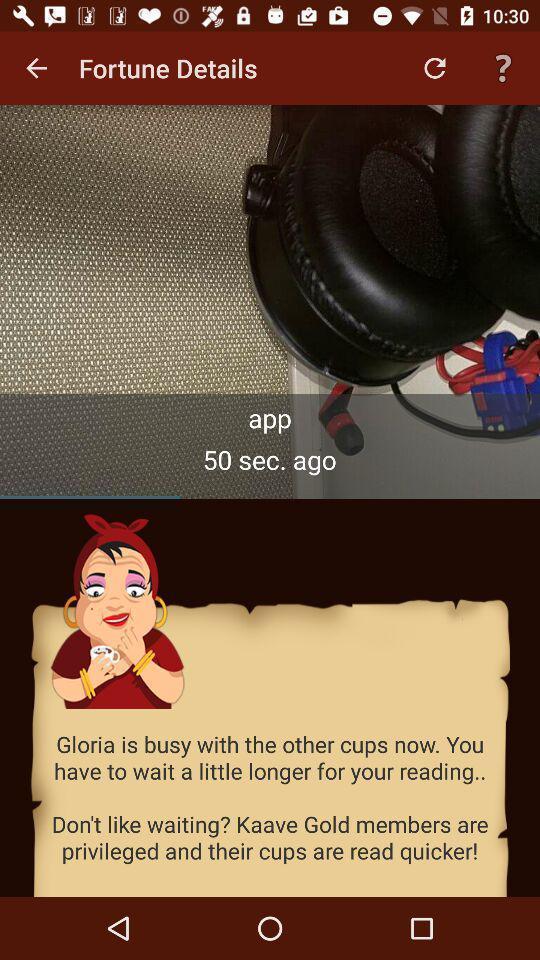Give me a narrative description of this picture. Pop up notification image. 